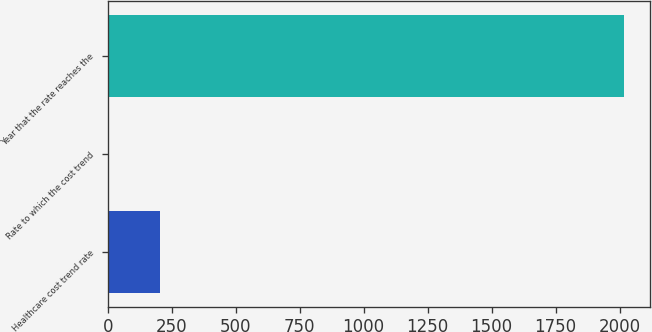Convert chart to OTSL. <chart><loc_0><loc_0><loc_500><loc_500><bar_chart><fcel>Healthcare cost trend rate<fcel>Rate to which the cost trend<fcel>Year that the rate reaches the<nl><fcel>205.85<fcel>4.5<fcel>2018<nl></chart> 